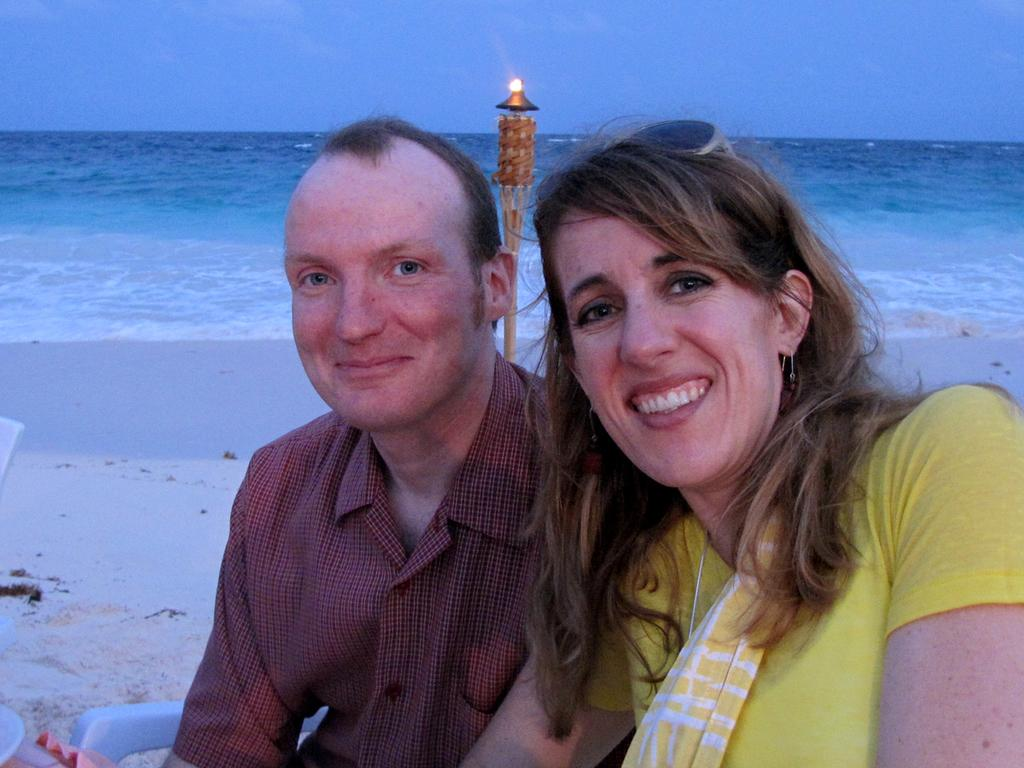Who is present in the image? There is a man and a woman in the image. What are the man and woman doing in the image? The man and woman are sitting. What is the emotional expression of the man and woman in the image? The man and woman are smiling. What type of location is depicted in the image? The image appears to be at a seashore. What natural element can be seen in the image? There is sea visible in the image. What is the movement of the water in the image? Water is flowing in the image. What type of musical instrument is the man playing in the image? There is no musical instrument present in the image; the man and woman are simply sitting and smiling. 